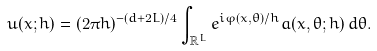<formula> <loc_0><loc_0><loc_500><loc_500>u ( x ; h ) = ( 2 \pi h ) ^ { - ( d + 2 L ) / 4 } \int _ { \mathbb { R } ^ { L } } e ^ { i \varphi ( x , \theta ) / h } a ( x , \theta ; h ) \, d \theta .</formula> 